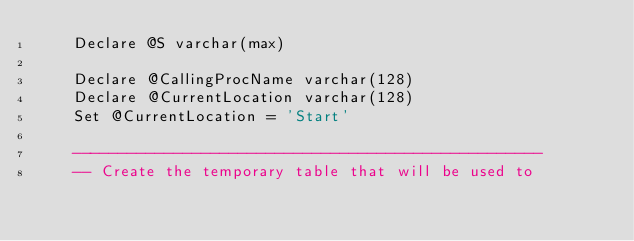Convert code to text. <code><loc_0><loc_0><loc_500><loc_500><_SQL_>    Declare @S varchar(max)

    Declare @CallingProcName varchar(128)
    Declare @CurrentLocation varchar(128)
    Set @CurrentLocation = 'Start'
    
    ---------------------------------------------------
    -- Create the temporary table that will be used to</code> 